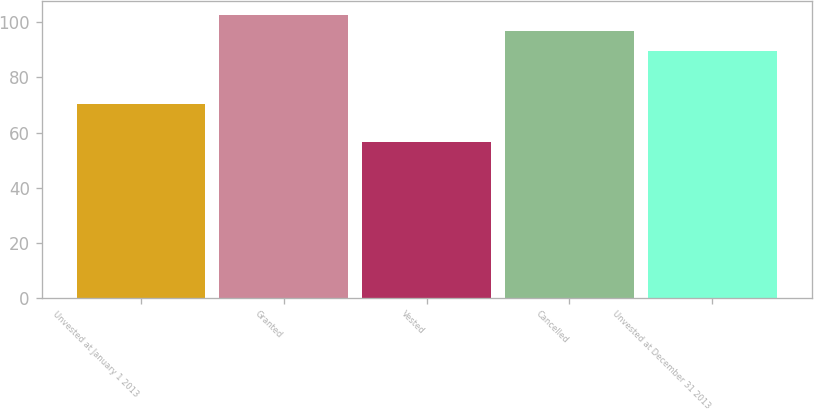Convert chart to OTSL. <chart><loc_0><loc_0><loc_500><loc_500><bar_chart><fcel>Unvested at January 1 2013<fcel>Granted<fcel>Vested<fcel>Cancelled<fcel>Unvested at December 31 2013<nl><fcel>70.28<fcel>102.69<fcel>56.43<fcel>96.9<fcel>89.58<nl></chart> 